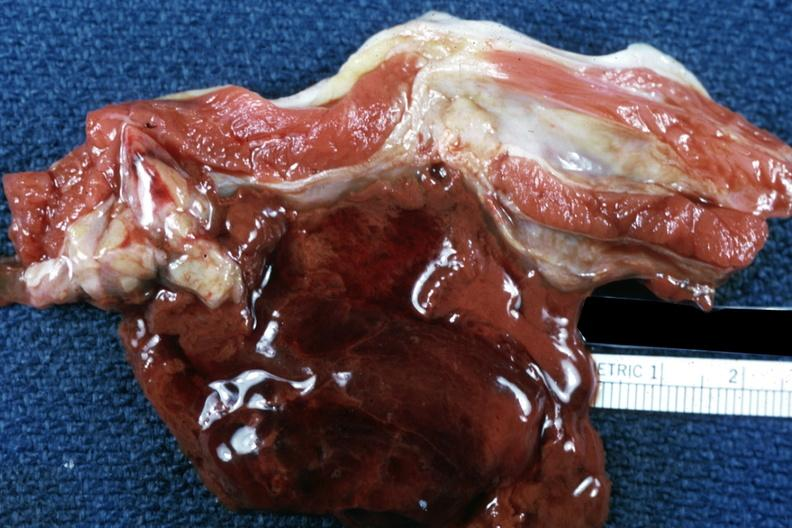what is present?
Answer the question using a single word or phrase. Muscle 